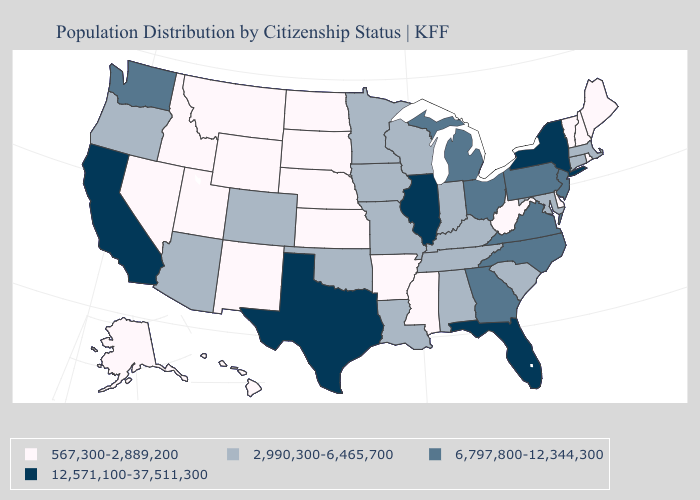Name the states that have a value in the range 2,990,300-6,465,700?
Short answer required. Alabama, Arizona, Colorado, Connecticut, Indiana, Iowa, Kentucky, Louisiana, Maryland, Massachusetts, Minnesota, Missouri, Oklahoma, Oregon, South Carolina, Tennessee, Wisconsin. Among the states that border Utah , which have the highest value?
Concise answer only. Arizona, Colorado. Does Pennsylvania have the same value as Kentucky?
Short answer required. No. Name the states that have a value in the range 12,571,100-37,511,300?
Write a very short answer. California, Florida, Illinois, New York, Texas. Which states have the lowest value in the USA?
Answer briefly. Alaska, Arkansas, Delaware, Hawaii, Idaho, Kansas, Maine, Mississippi, Montana, Nebraska, Nevada, New Hampshire, New Mexico, North Dakota, Rhode Island, South Dakota, Utah, Vermont, West Virginia, Wyoming. What is the value of Illinois?
Write a very short answer. 12,571,100-37,511,300. Which states have the lowest value in the West?
Be succinct. Alaska, Hawaii, Idaho, Montana, Nevada, New Mexico, Utah, Wyoming. What is the lowest value in states that border Vermont?
Short answer required. 567,300-2,889,200. Name the states that have a value in the range 6,797,800-12,344,300?
Keep it brief. Georgia, Michigan, New Jersey, North Carolina, Ohio, Pennsylvania, Virginia, Washington. Name the states that have a value in the range 567,300-2,889,200?
Write a very short answer. Alaska, Arkansas, Delaware, Hawaii, Idaho, Kansas, Maine, Mississippi, Montana, Nebraska, Nevada, New Hampshire, New Mexico, North Dakota, Rhode Island, South Dakota, Utah, Vermont, West Virginia, Wyoming. Does Utah have the lowest value in the West?
Answer briefly. Yes. Name the states that have a value in the range 6,797,800-12,344,300?
Short answer required. Georgia, Michigan, New Jersey, North Carolina, Ohio, Pennsylvania, Virginia, Washington. What is the lowest value in states that border Florida?
Give a very brief answer. 2,990,300-6,465,700. What is the value of Illinois?
Concise answer only. 12,571,100-37,511,300. 